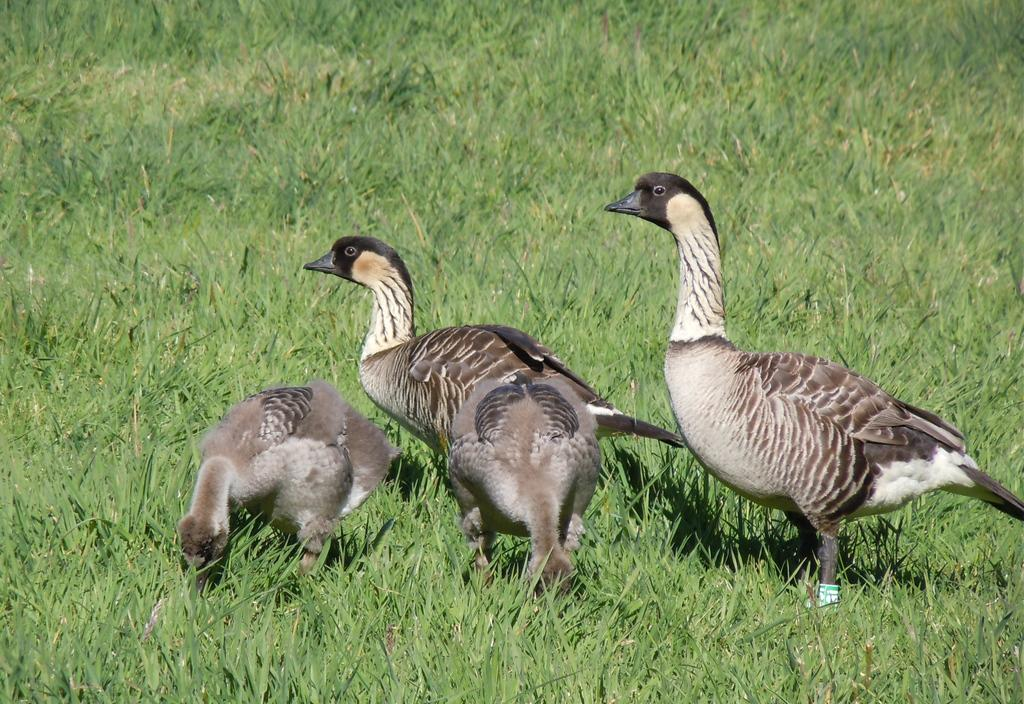What type of animals can be seen in the image? Birds can be seen in the image. Where are the birds located in the image? The birds are on the grass. What type of group development and respect can be observed among the birds in the image? There is no information about group development or respect among the birds in the image, as it only shows birds on the grass. 